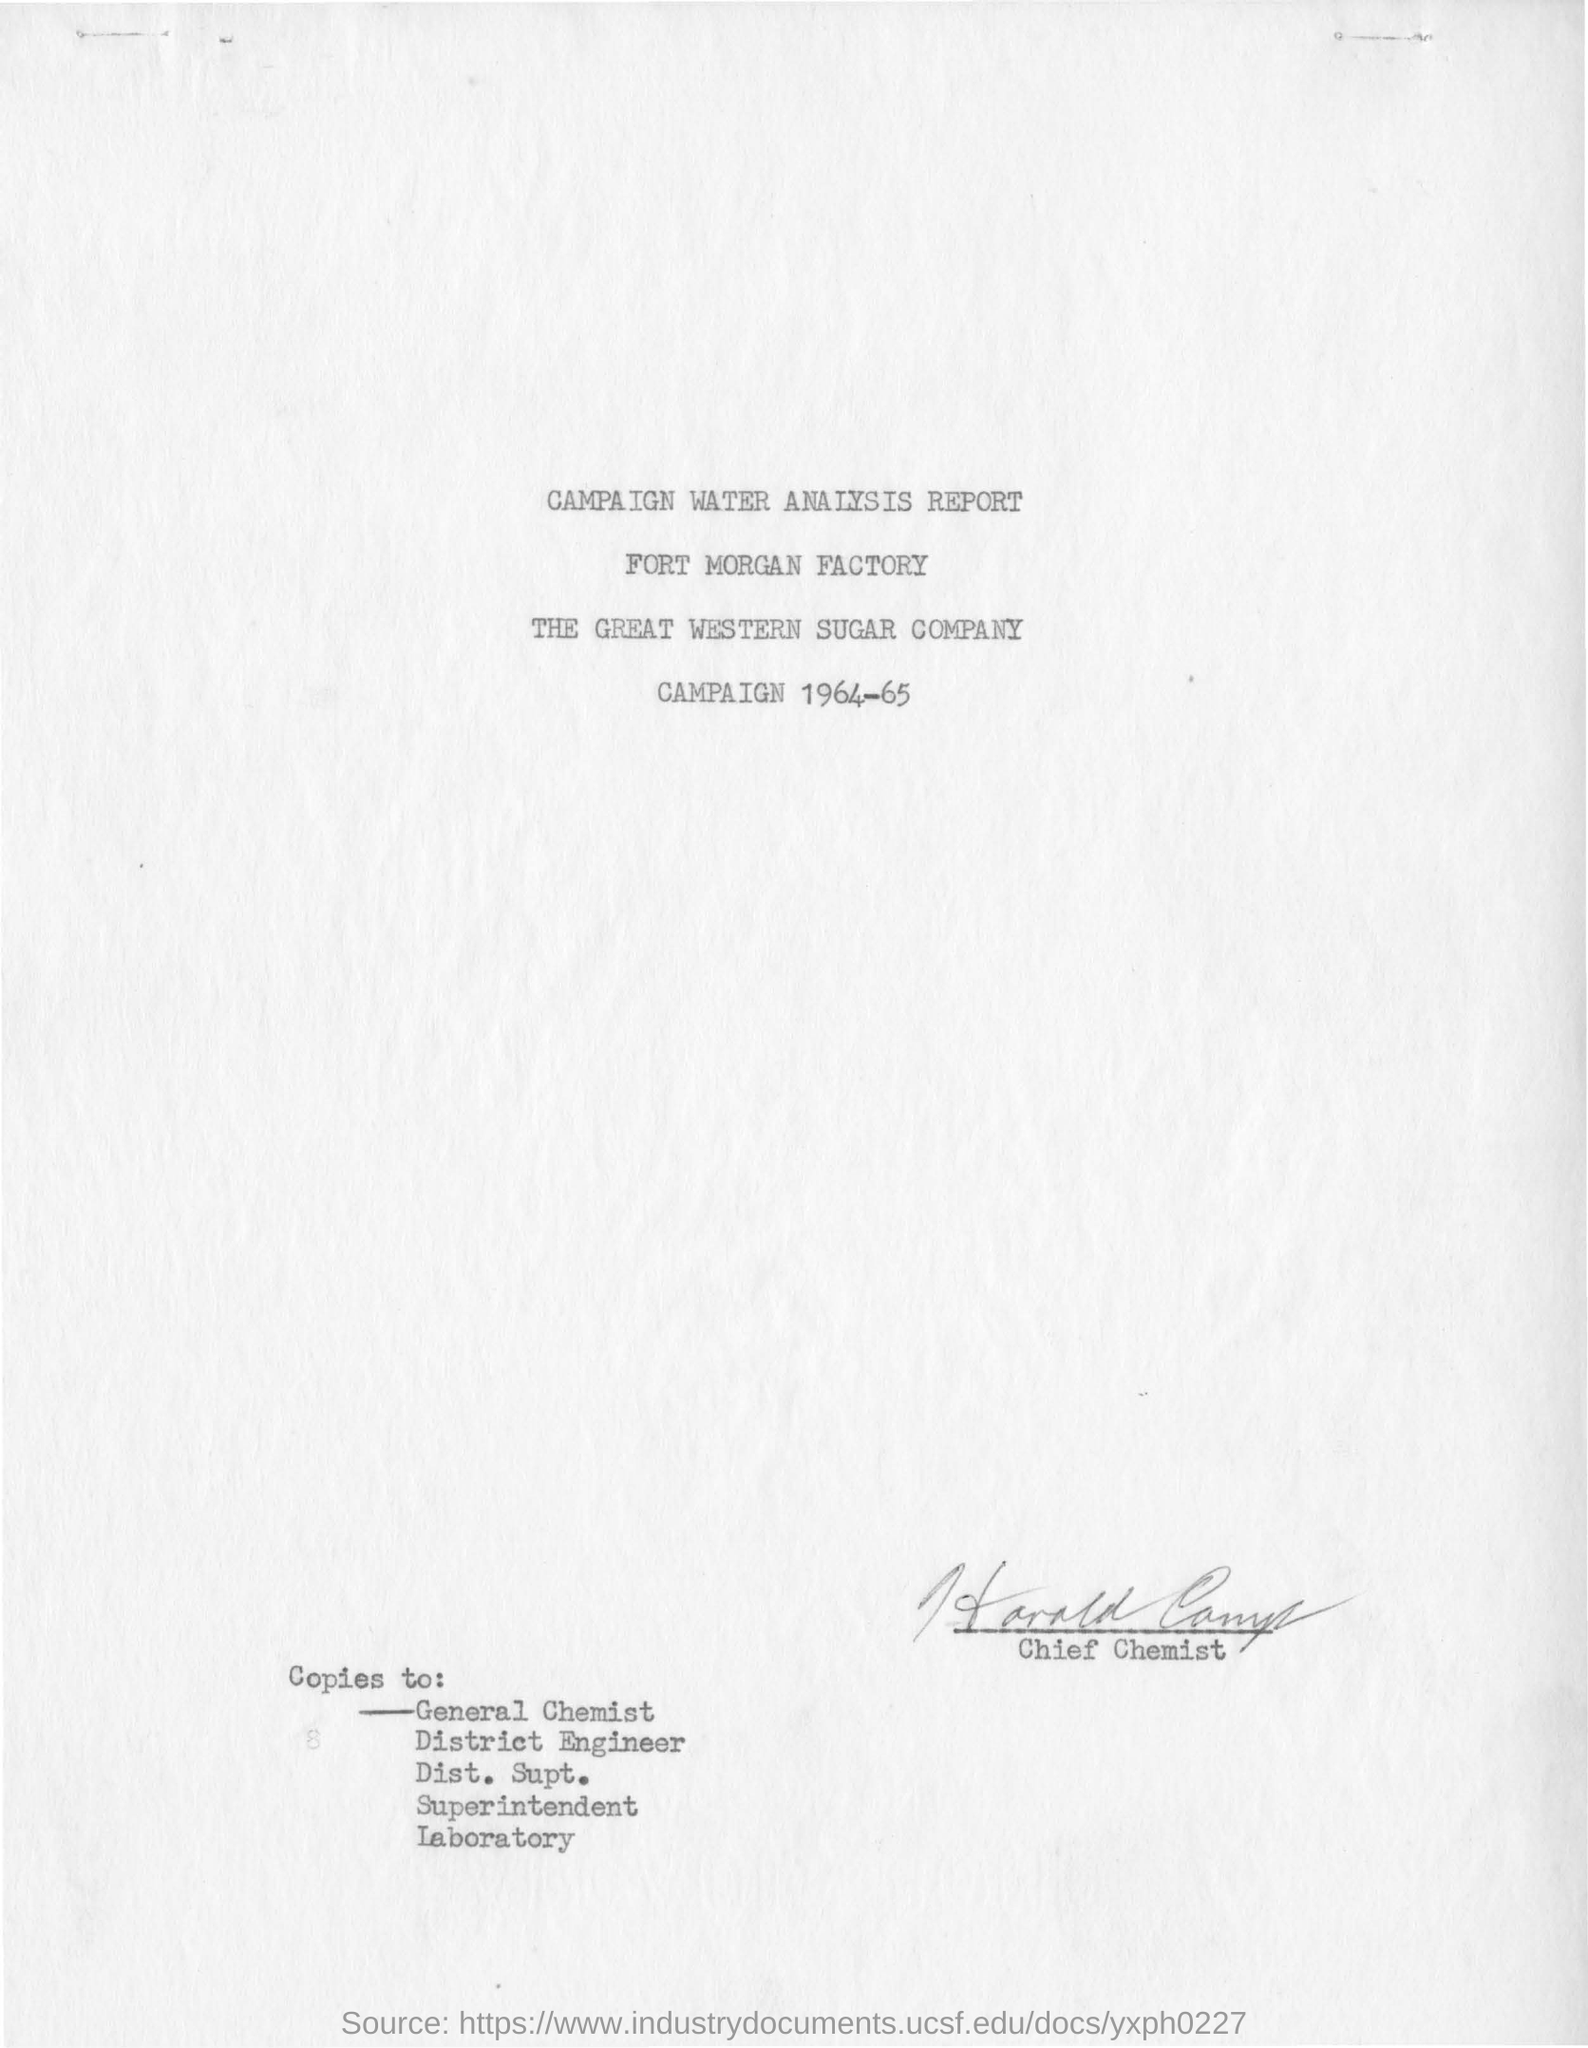Indicate a few pertinent items in this graphic. The Fort Morgan Factory is mentioned in the campaign water analysis report. This campaign report is from the years 1964 and 1965. 